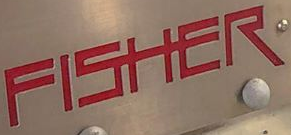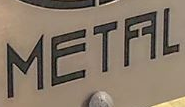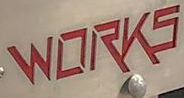Read the text from these images in sequence, separated by a semicolon. FISHER; METFFL; WORKS 